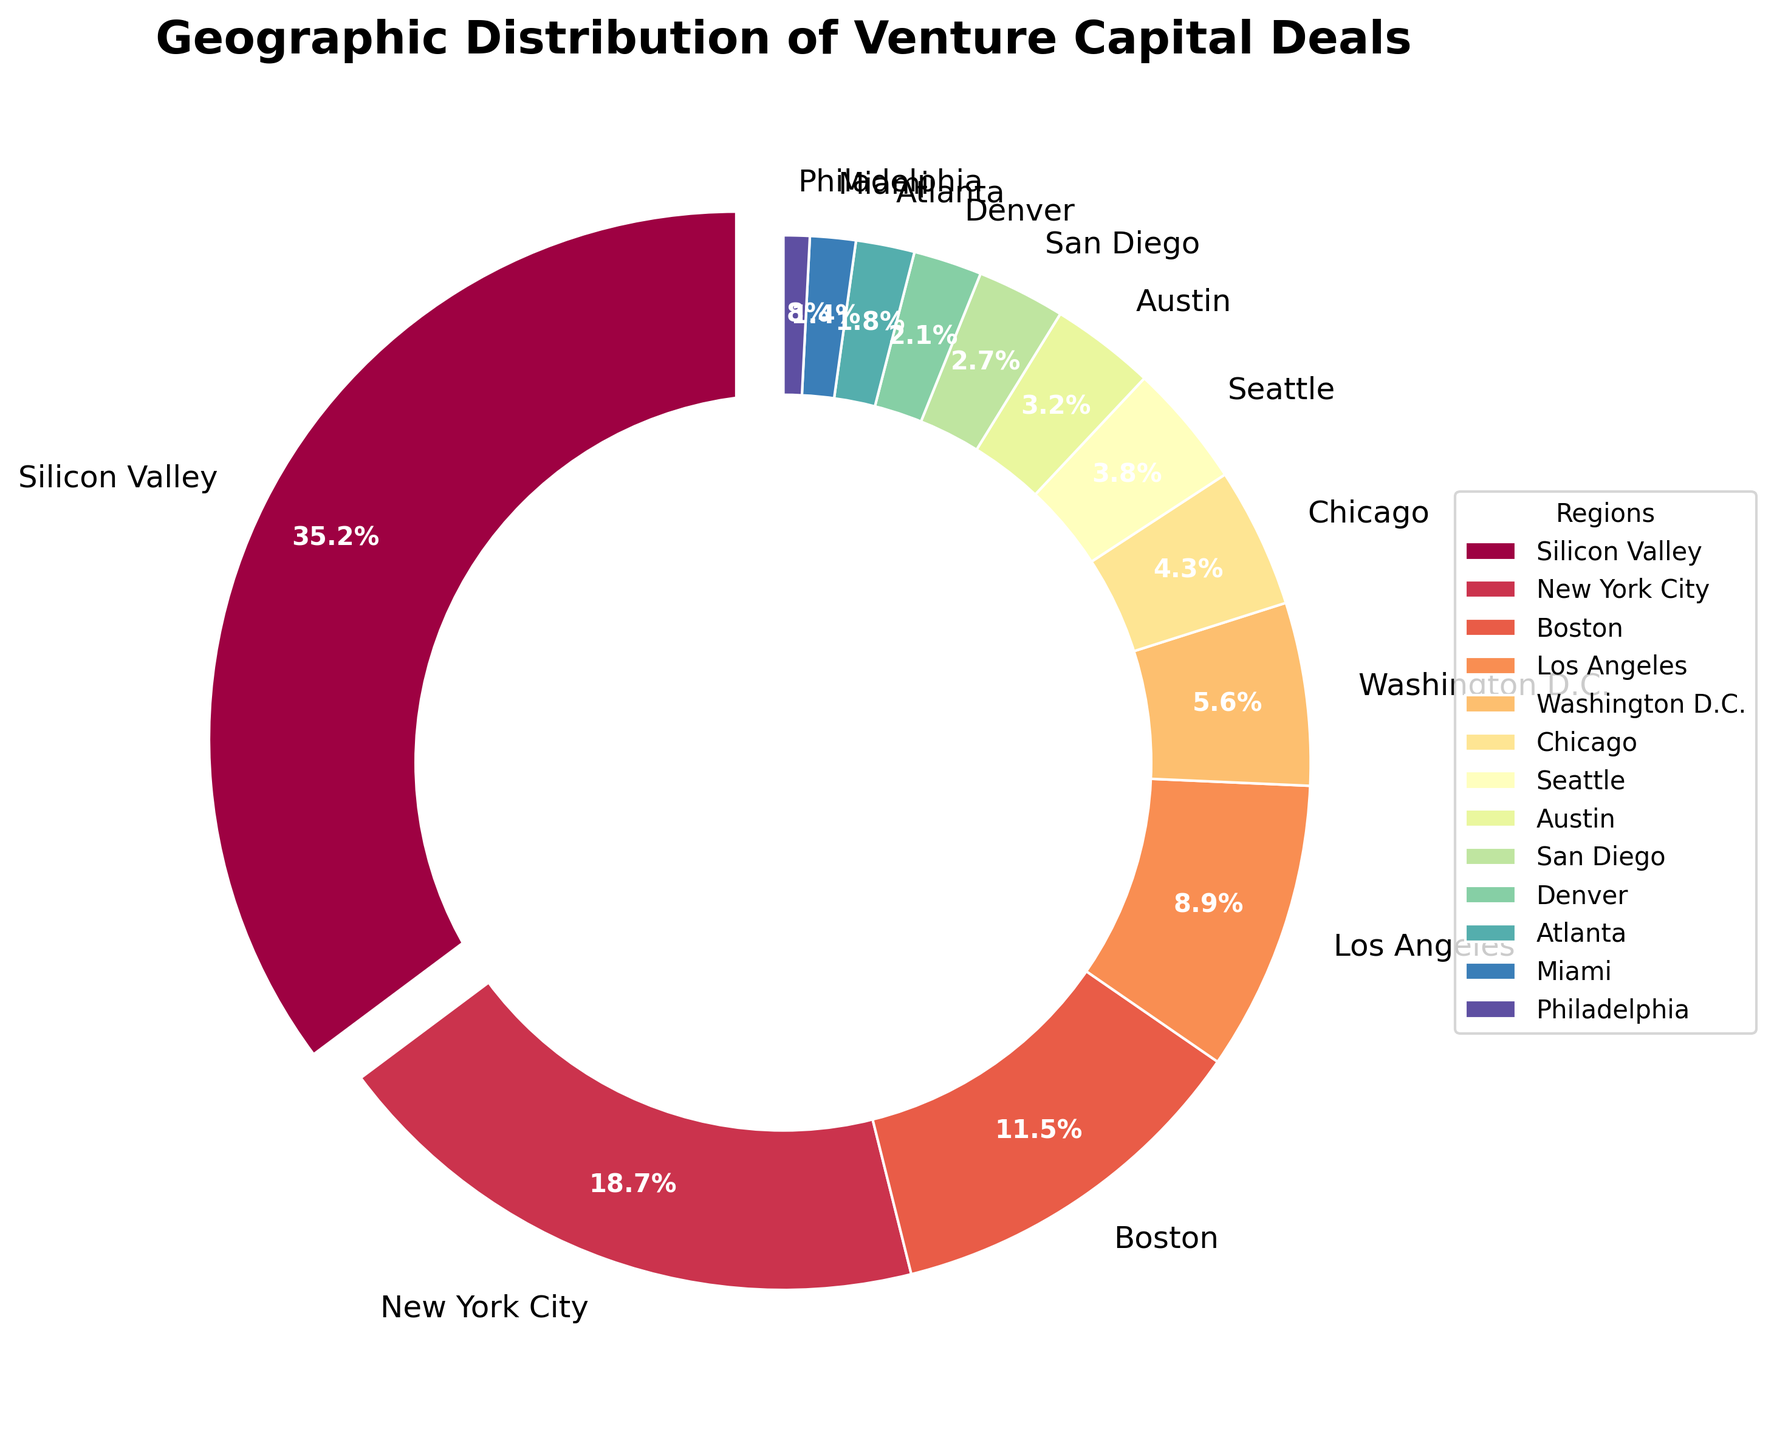What percentage of venture capital deals took place in New York City? The percentage for New York City can be directly read from the figure. It's labeled as 18.7%.
Answer: 18.7% Which region has the third highest percentage of venture capital deals, and what is that percentage? By looking at the pie chart, the third highest percentage is represented by Boston, which has 11.5%.
Answer: Boston, 11.5% What is the total percentage of venture capital deals in the top three regions? Sum the percentages of Silicon Valley, New York City, and Boston: 35.2% + 18.7% + 11.5% = 65.4%.
Answer: 65.4% Is the percentage of deals in Los Angeles greater than those in Washington D.C. and Chicago combined? Check the percentages: Los Angeles has 8.9%, Washington D.C. has 5.6%, and Chicago has 4.3%. Sum Washington D.C. and Chicago: 5.6% + 4.3% = 9.9%. Compare 8.9% (Los Angeles) with 9.9%.
Answer: No How much larger is the percentage of venture capital deals in Silicon Valley compared to Austin? Subtract Austin's percentage from Silicon Valley's: 35.2% - 3.2% = 32%.
Answer: 32% Which regions make up less than 3% of venture capital deals each? From the chart, we can see that San Diego (2.7%), Denver (2.1%), Atlanta (1.8%), Miami (1.4%), and Philadelphia (0.8%) each have less than 3%.
Answer: San Diego, Denver, Atlanta, Miami, Philadelphia What is the average percentage of venture capital deals for regions with more than 10% share? First identify the regions with more than 10%: Silicon Valley (35.2%), New York City (18.7%), and Boston (11.5%). Calculate the average: (35.2% + 18.7% + 11.5%) / 3 ≈ 21.8%.
Answer: 21.8% Which region has the smallest percentage of venture capital deals, and what is that percentage? The region with the smallest percentage is Philadelphia with 0.8%.
Answer: Philadelphia, 0.8% What combined percentage of venture capital deals is represented by regions that have between 5% and 10% share? Identify the regions within the range: Los Angeles (8.9%) and Washington D.C. (5.6%). Sum their percentages: 8.9% + 5.6% = 14.5%.
Answer: 14.5% 